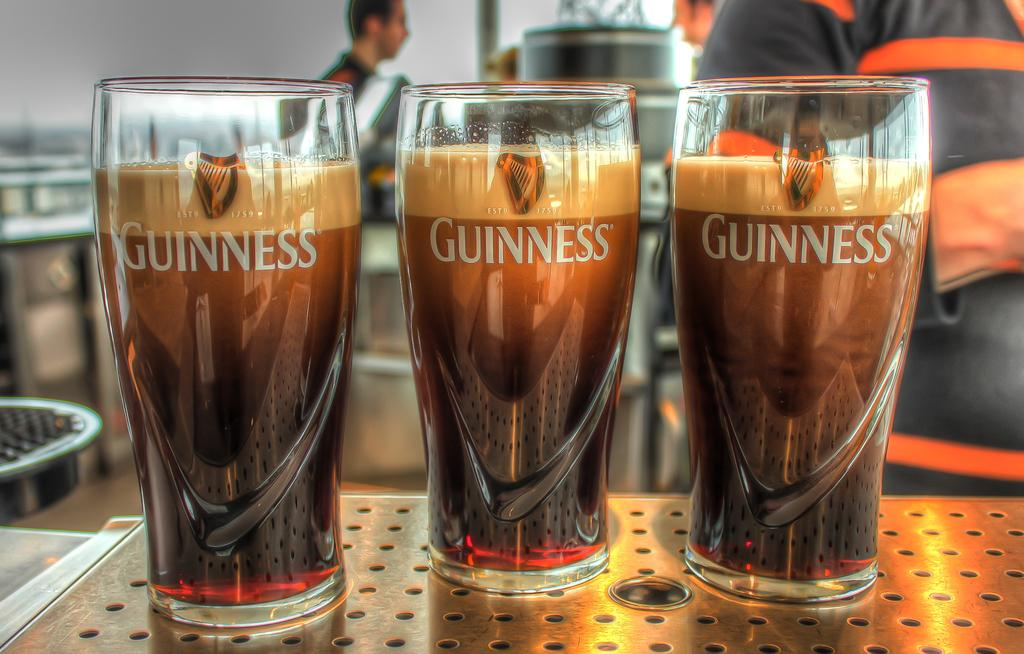<image>
Render a clear and concise summary of the photo. Three glasses of Guiness filled with a drink 